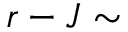Convert formula to latex. <formula><loc_0><loc_0><loc_500><loc_500>r - J \sim</formula> 